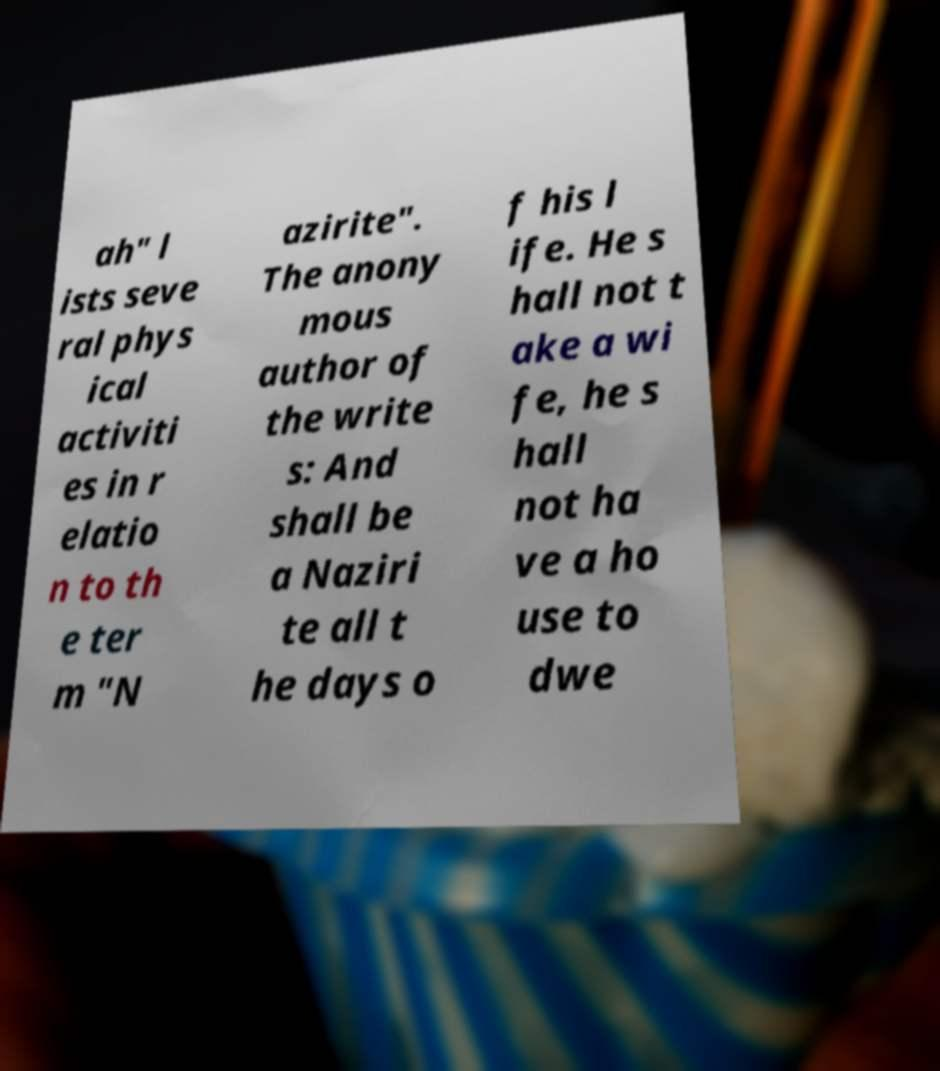There's text embedded in this image that I need extracted. Can you transcribe it verbatim? ah" l ists seve ral phys ical activiti es in r elatio n to th e ter m "N azirite". The anony mous author of the write s: And shall be a Naziri te all t he days o f his l ife. He s hall not t ake a wi fe, he s hall not ha ve a ho use to dwe 